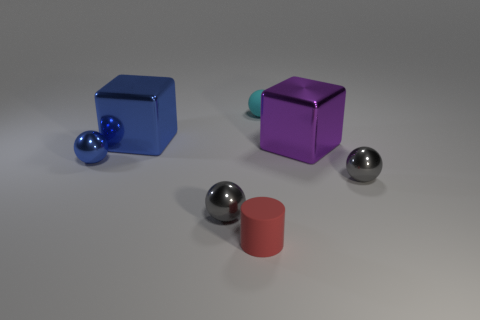Are there any signs that indicate what the objects could be used for? The objects in the image don't have any clear markings or features that would indicate a specific use. They appear to be simple geometric shapes, possibly for a visual demonstration or a rendering test for lighting and materials. 